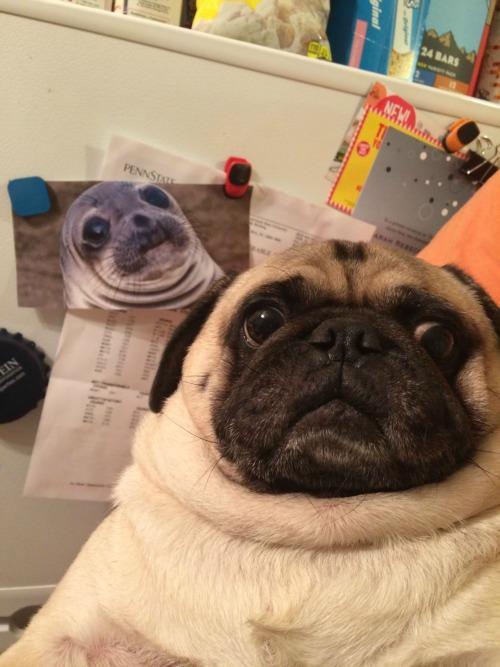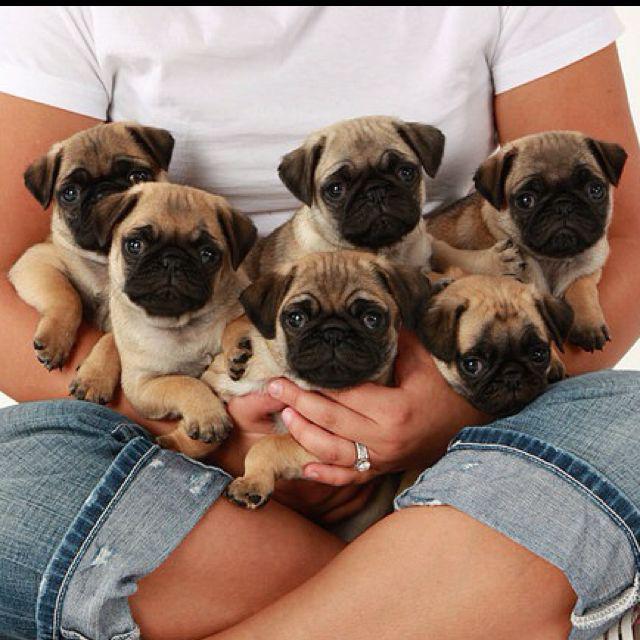The first image is the image on the left, the second image is the image on the right. Analyze the images presented: Is the assertion "There are two puppies" valid? Answer yes or no. No. The first image is the image on the left, the second image is the image on the right. For the images displayed, is the sentence "There are two puppies total." factually correct? Answer yes or no. No. 